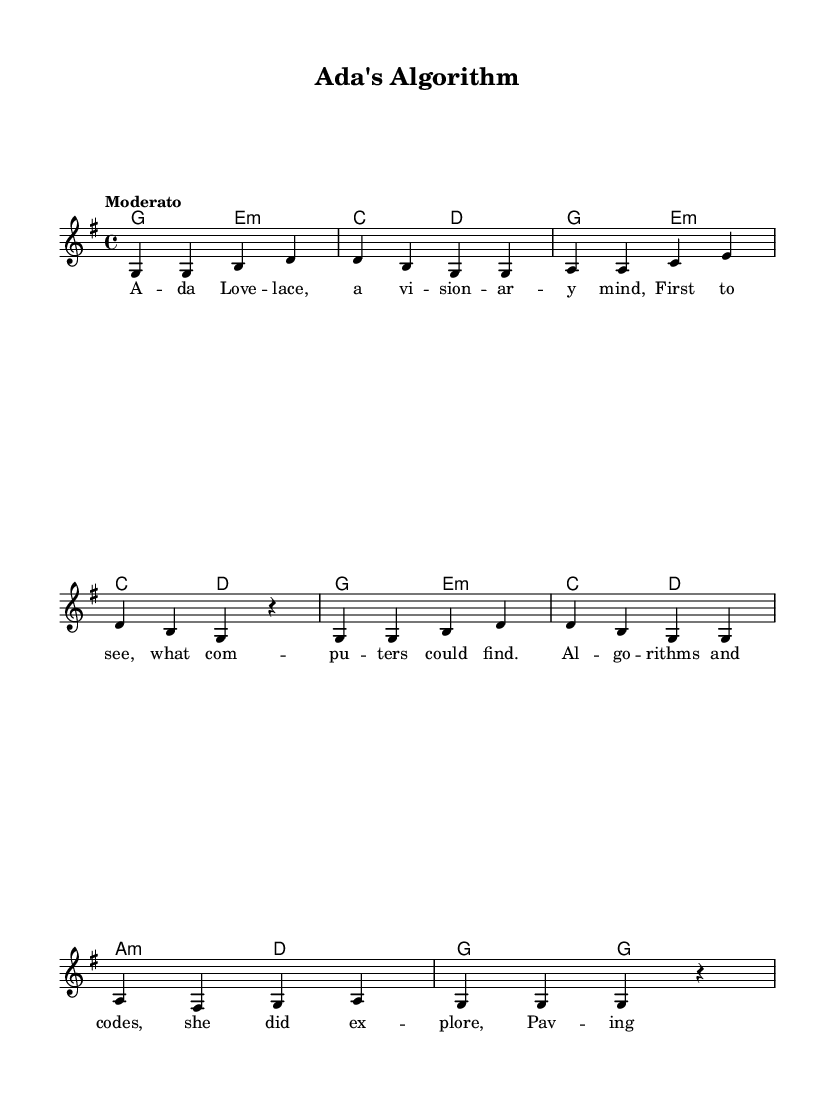What is the key signature of this music? The key signature at the beginning of the sheet music indicates the key of G major, which has one sharp (F#).
Answer: G major What is the time signature of this piece? The time signature shown at the beginning of the sheet music is 4/4, which means there are four beats in each measure and a quarter note gets one beat.
Answer: 4/4 What is the tempo marking for this piece? The tempo marking provided in the sheet music is "Moderato," which indicates a moderate pace for the song.
Answer: Moderato How many measures are in the melody section? By counting the measures in the melody, there are a total of 8 measures present in this melody section.
Answer: 8 Which pioneering woman is this song about? The lyrics in the sheet music refer to Ada Lovelace, who is recognized as a visionary in the field of computing.
Answer: Ada Lovelace What is the main theme conveyed in the lyrics? The lyrics highlight Ada Lovelace's contributions to computer science, especially her work on algorithms and paving the way for future developments in technology.
Answer: Contributions to computer science What kind of musical form is being used in this piece? The structure of the song follows a verse format, which is common in folk music, featuring lyrics that tell a story.
Answer: Verse format 